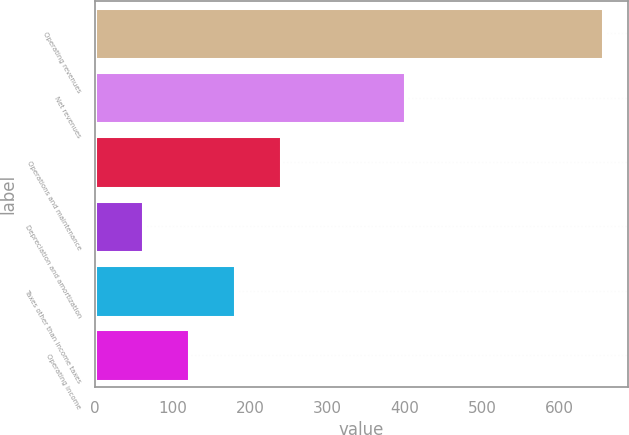<chart> <loc_0><loc_0><loc_500><loc_500><bar_chart><fcel>Operating revenues<fcel>Net revenues<fcel>Operations and maintenance<fcel>Depreciation and amortization<fcel>Taxes other than income taxes<fcel>Operating income<nl><fcel>656<fcel>400<fcel>240.2<fcel>62<fcel>180.8<fcel>121.4<nl></chart> 